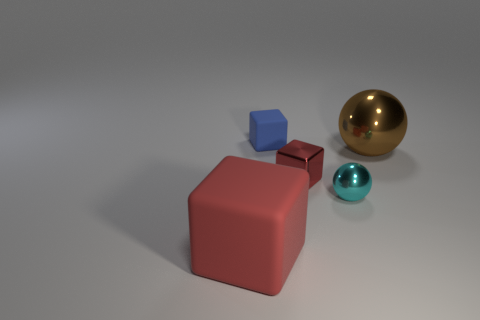Is the small blue cube made of the same material as the big thing that is in front of the big brown metallic object?
Offer a very short reply. Yes. What material is the tiny cube that is the same color as the big block?
Ensure brevity in your answer.  Metal. What number of other big metal balls are the same color as the large ball?
Ensure brevity in your answer.  0. The brown metal thing is what size?
Make the answer very short. Large. There is a big matte object; is its shape the same as the tiny metal thing behind the small shiny sphere?
Provide a short and direct response. Yes. There is a tiny block that is made of the same material as the brown object; what is its color?
Keep it short and to the point. Red. What size is the cube behind the small red metal cube?
Keep it short and to the point. Small. Are there fewer brown things that are left of the small red shiny block than big red matte cubes?
Ensure brevity in your answer.  Yes. Does the metal cube have the same color as the small shiny sphere?
Your answer should be very brief. No. Are there fewer tiny matte cubes than tiny things?
Provide a succinct answer. Yes. 